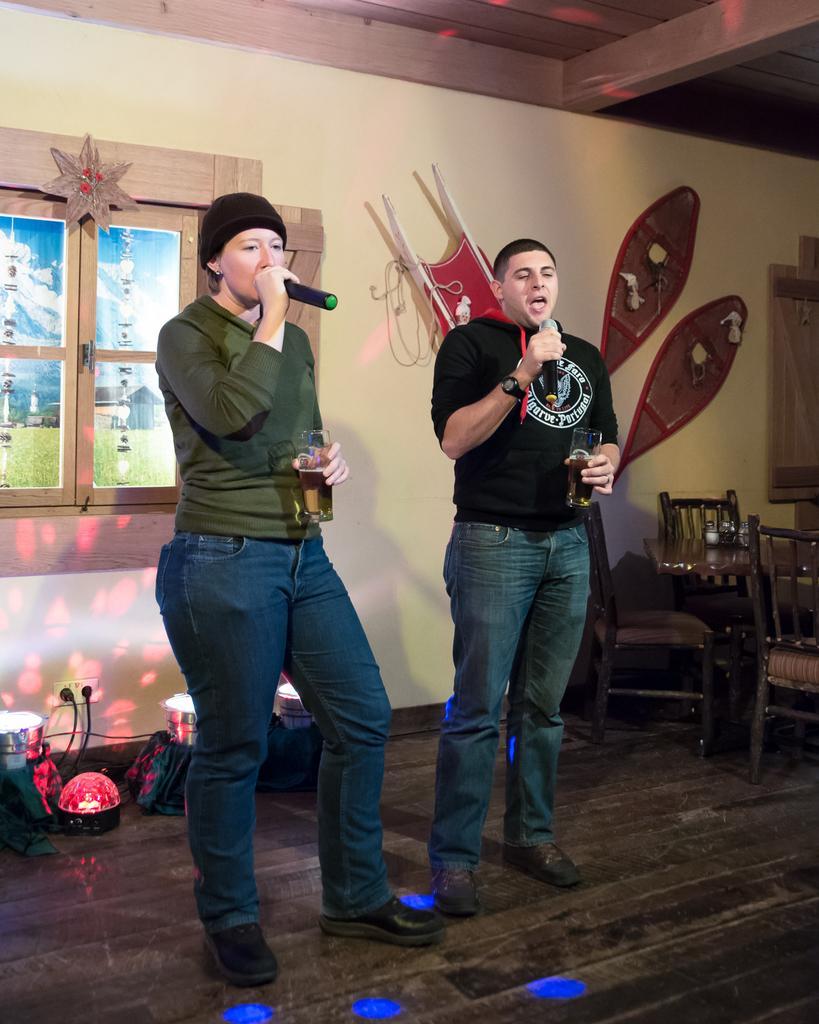Can you describe this image briefly? In this image we can see a man and a woman standing on the floor holding the miles and glasses. We can also see some chairs, plugs to a switch board, ceiling lights, a window, some decors, a wall and a roof. 